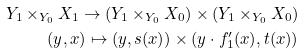<formula> <loc_0><loc_0><loc_500><loc_500>Y _ { 1 } \times _ { Y _ { 0 } } X _ { 1 } \to ( Y _ { 1 } \times _ { Y _ { 0 } } X _ { 0 } ) \times ( Y _ { 1 } \times _ { Y _ { 0 } } X _ { 0 } ) \\ ( y , x ) \mapsto ( y , s ( x ) ) \times ( y \cdot f ^ { \prime } _ { 1 } ( x ) , t ( x ) )</formula> 